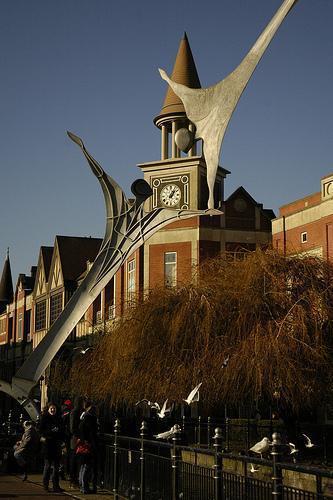How many figures are on the statue?
Give a very brief answer. 2. 